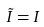<formula> <loc_0><loc_0><loc_500><loc_500>\tilde { I } = I</formula> 